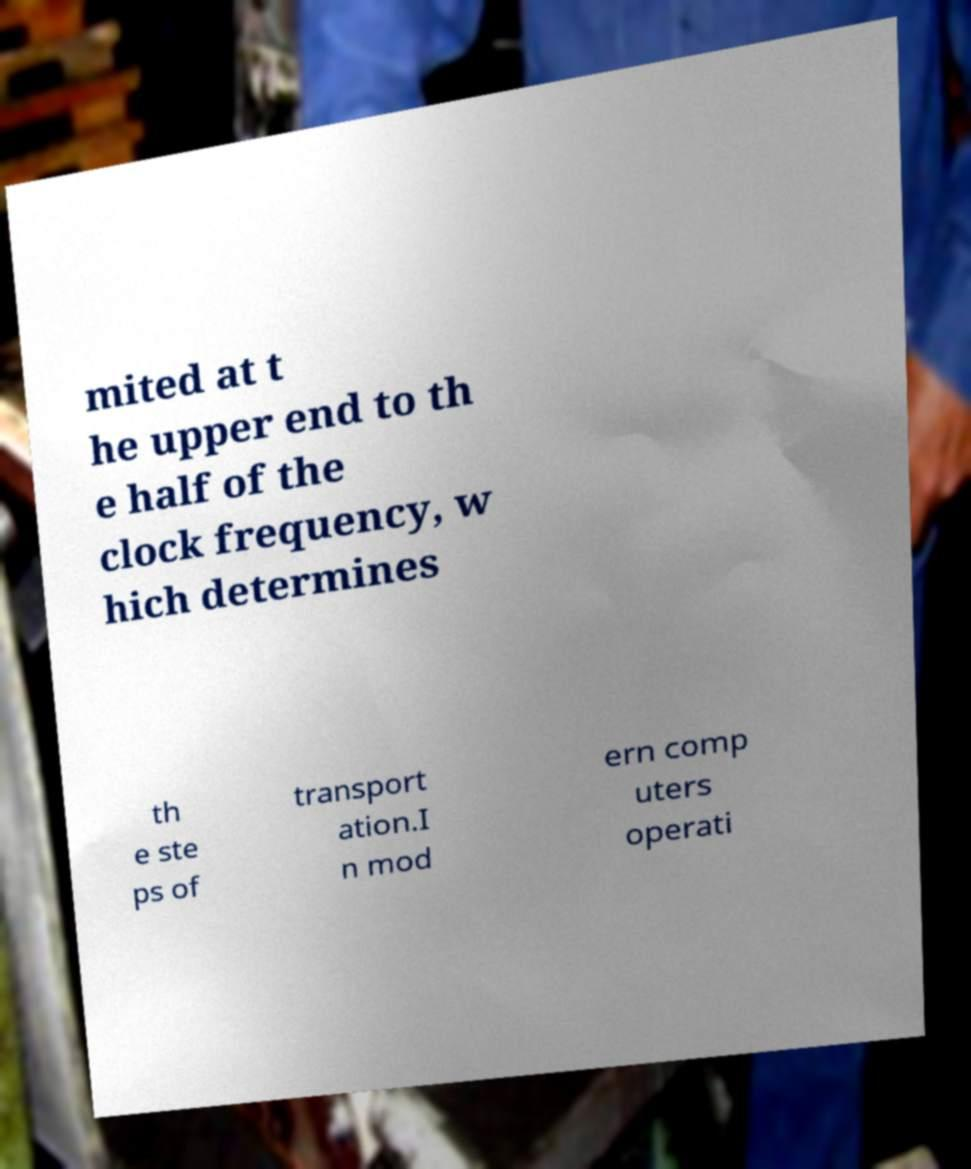Please read and relay the text visible in this image. What does it say? mited at t he upper end to th e half of the clock frequency, w hich determines th e ste ps of transport ation.I n mod ern comp uters operati 